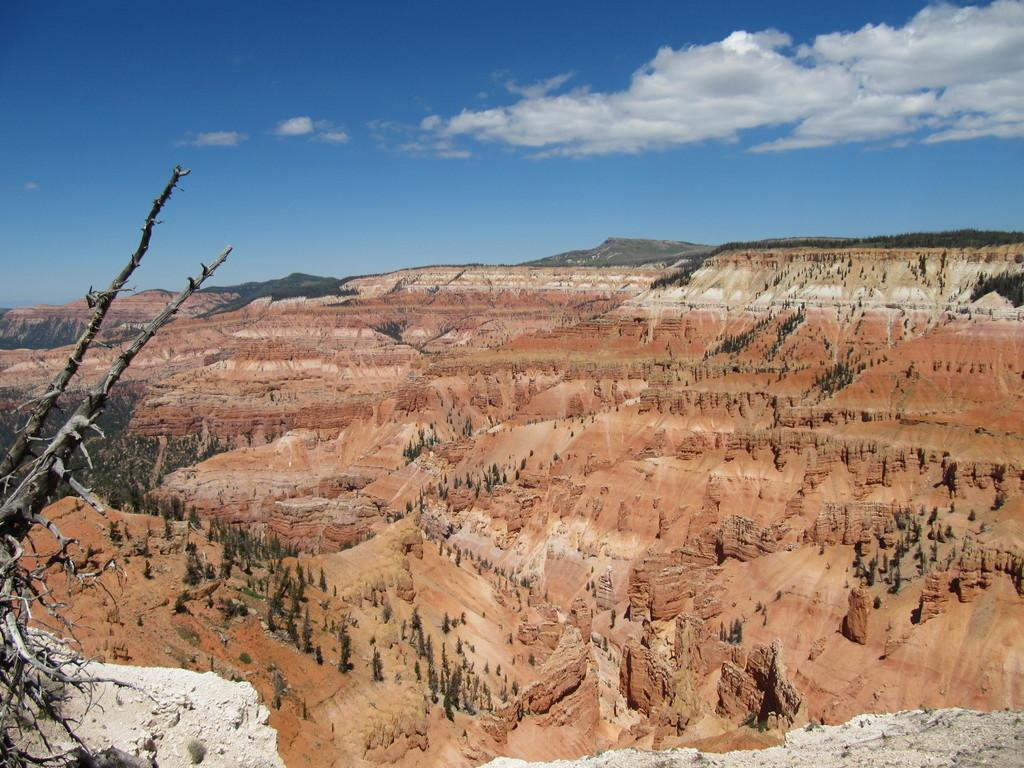What can be seen in the foreground of the image? There are branches without leaves in the foreground of the image. What is visible in the background of the image? There are trees and cliffs in the background of the image. How would you describe the terrain in the background of the image? The ground is uneven in the background of the image. What is visible at the top of the image? The sky is visible at the top of the image. Can you see a zipper on any of the branches in the image? There is no zipper present on the branches in the image. Is there a yoke visible on any of the trees in the background? There is no yoke present on any of the trees in the background of the image. 